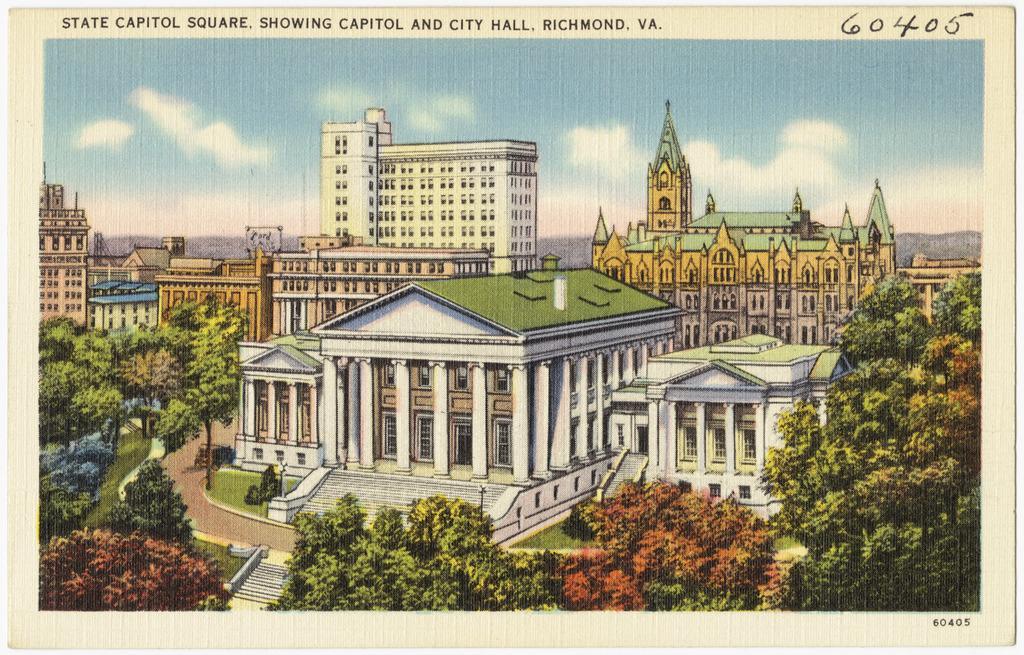How would you summarize this image in a sentence or two? In this image, we can see some buildings and trees. There are clouds in the sky. There is a text at the top of the image. 